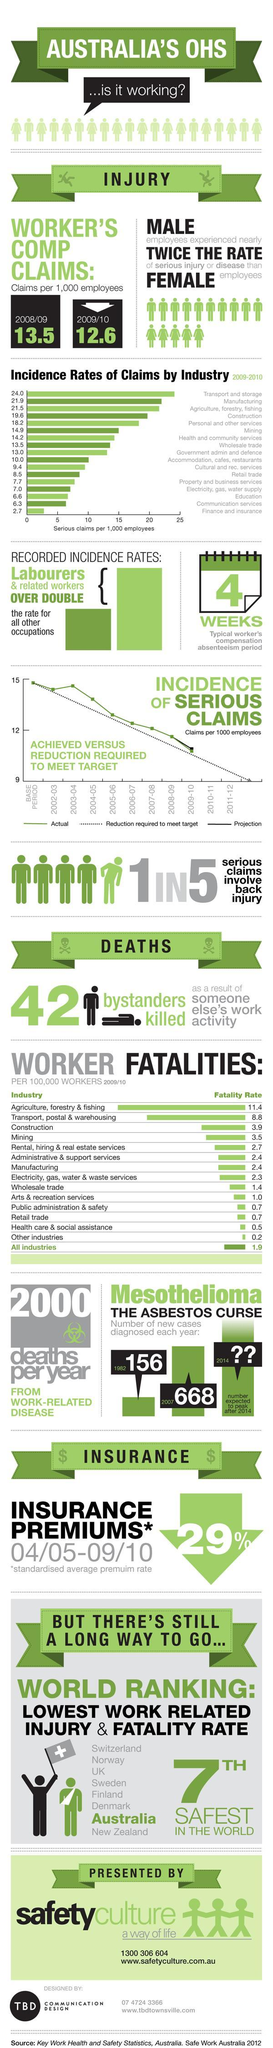Which industry has the third highest incidence rates of claims?
Answer the question with a short phrase. Agriculture, forestry, fishing What is the incidence rate of claims in Finance and insurance as well as Communication services per 1000 employees in 2009-2010?? 9 By what has claims per 1,000 employees decreased from 2008/09 to 2009/10? 0.9 How many sources are listed at the bottom? 1 Which two industries have a fatality rate of 0.7 per 100,000 workers as of 2009/10? Public administration & safety, Retail trade 